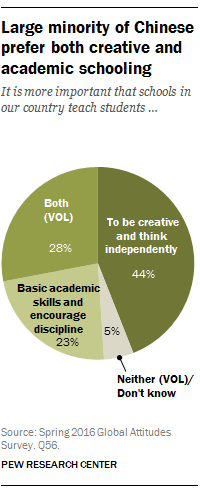Highlight a few significant elements in this photo. The grey color section is the minimal value in the chart, and it is. The average of the three largest values in the chart is approximately 31.67. 